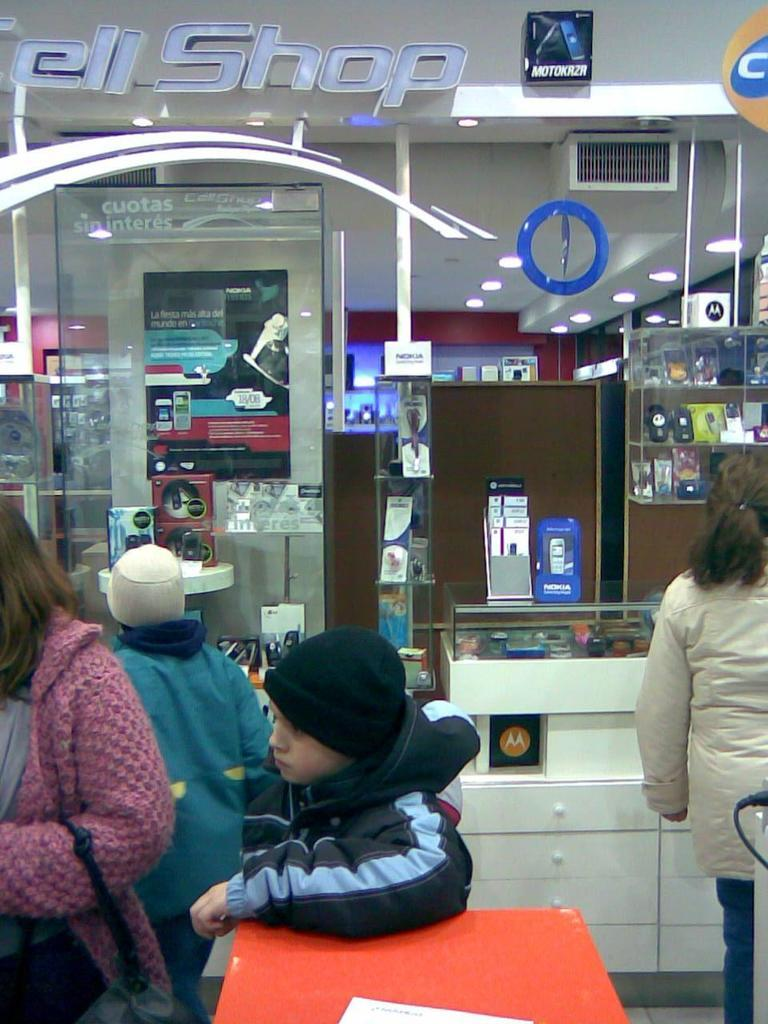<image>
Share a concise interpretation of the image provided. Customers in a store with the words "ell Shop" visible on top 